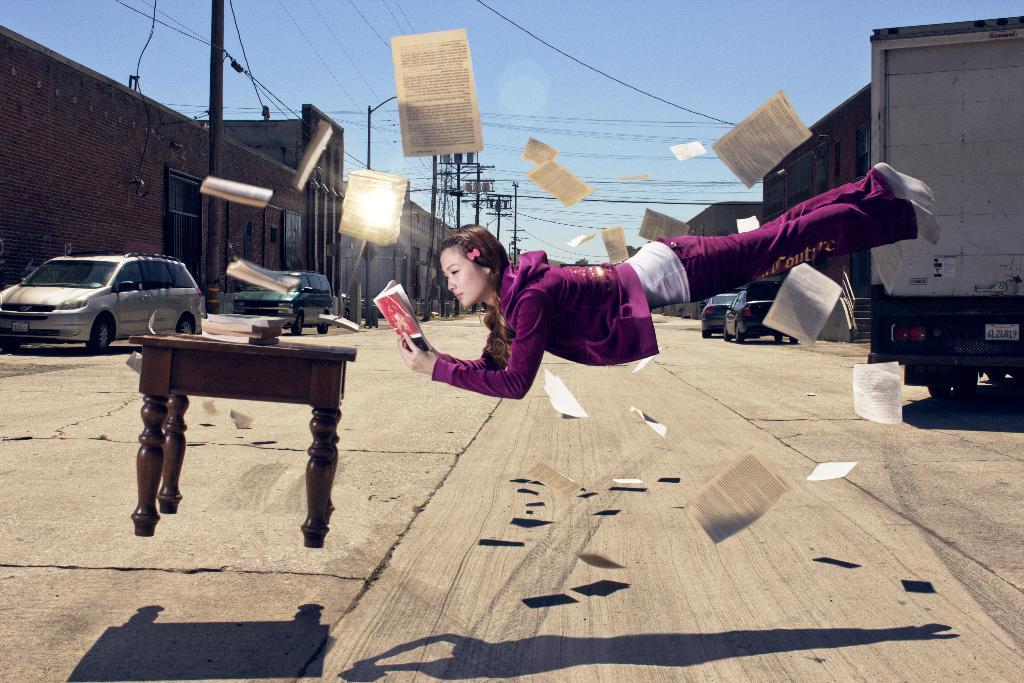Describe this image in one or two sentences. This is a graphical picture we see a woman flying holding a book in her hand and we see a table in the air and we see few papers flying. we see a truck and a building and couple of cars parked on the road 